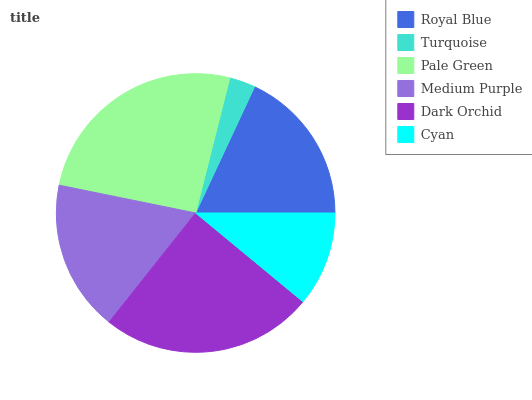Is Turquoise the minimum?
Answer yes or no. Yes. Is Pale Green the maximum?
Answer yes or no. Yes. Is Pale Green the minimum?
Answer yes or no. No. Is Turquoise the maximum?
Answer yes or no. No. Is Pale Green greater than Turquoise?
Answer yes or no. Yes. Is Turquoise less than Pale Green?
Answer yes or no. Yes. Is Turquoise greater than Pale Green?
Answer yes or no. No. Is Pale Green less than Turquoise?
Answer yes or no. No. Is Royal Blue the high median?
Answer yes or no. Yes. Is Medium Purple the low median?
Answer yes or no. Yes. Is Pale Green the high median?
Answer yes or no. No. Is Dark Orchid the low median?
Answer yes or no. No. 